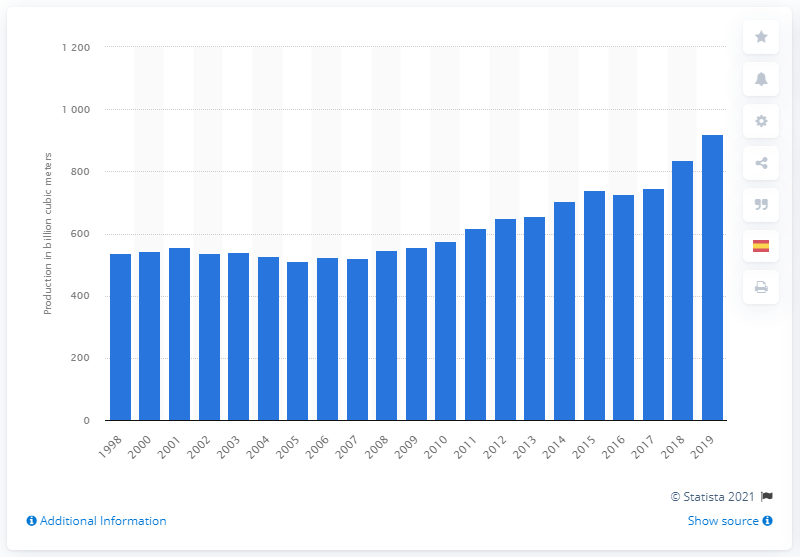List a handful of essential elements in this visual. In 2019, the United States produced 920.9 billion cubic meters of natural gas. During the 2008 recession, it occurred in that year. 